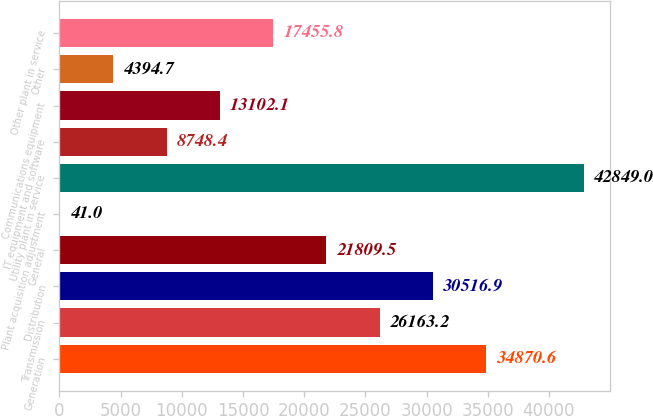<chart> <loc_0><loc_0><loc_500><loc_500><bar_chart><fcel>Generation<fcel>Transmission<fcel>Distribution<fcel>General<fcel>Plant acquisition adjustment<fcel>Utility plant in service<fcel>IT equipment and software<fcel>Communications equipment<fcel>Other<fcel>Other plant in service<nl><fcel>34870.6<fcel>26163.2<fcel>30516.9<fcel>21809.5<fcel>41<fcel>42849<fcel>8748.4<fcel>13102.1<fcel>4394.7<fcel>17455.8<nl></chart> 